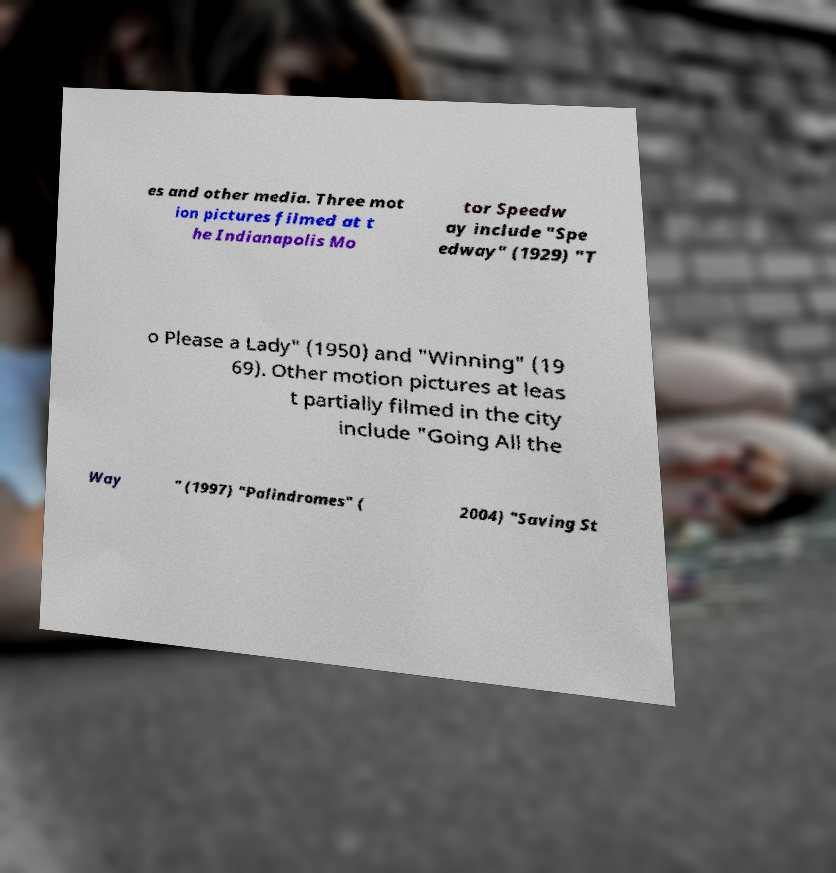Can you accurately transcribe the text from the provided image for me? es and other media. Three mot ion pictures filmed at t he Indianapolis Mo tor Speedw ay include "Spe edway" (1929) "T o Please a Lady" (1950) and "Winning" (19 69). Other motion pictures at leas t partially filmed in the city include "Going All the Way " (1997) "Palindromes" ( 2004) "Saving St 